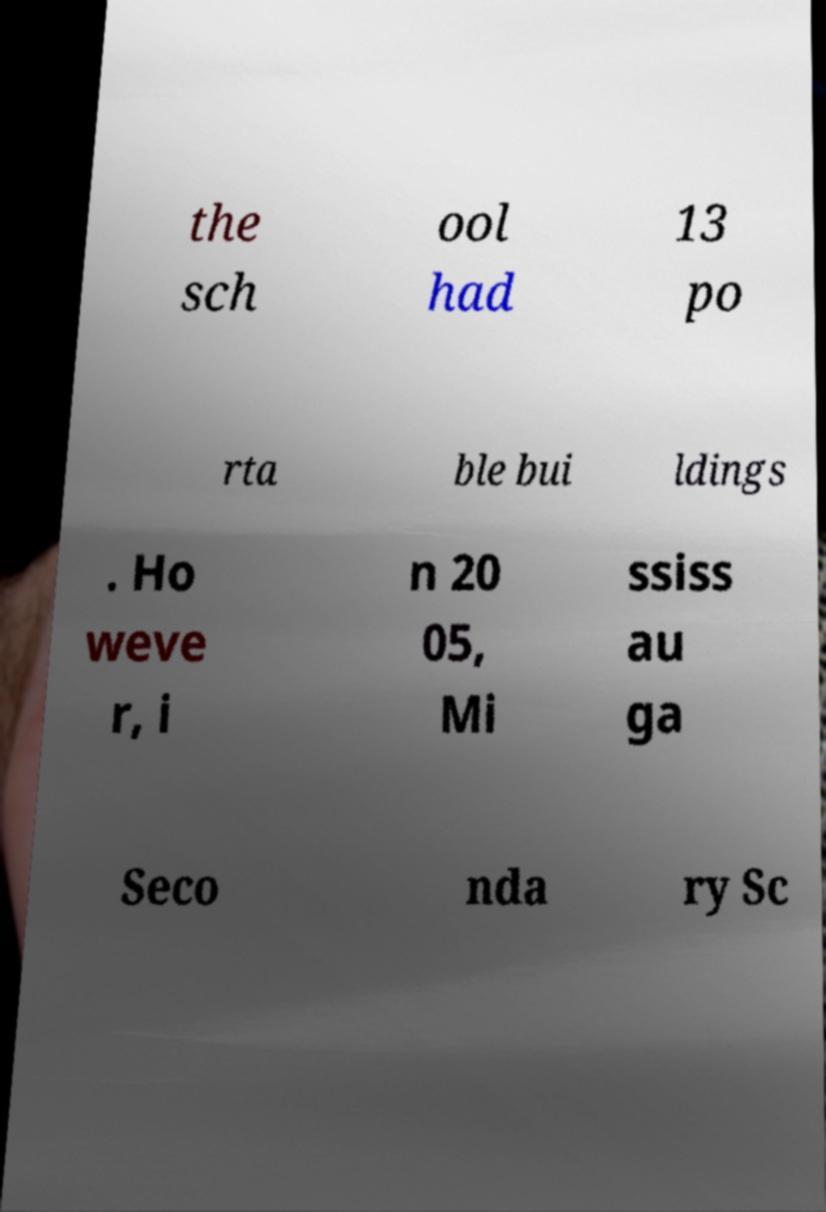Can you read and provide the text displayed in the image?This photo seems to have some interesting text. Can you extract and type it out for me? the sch ool had 13 po rta ble bui ldings . Ho weve r, i n 20 05, Mi ssiss au ga Seco nda ry Sc 